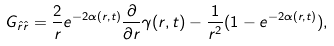Convert formula to latex. <formula><loc_0><loc_0><loc_500><loc_500>G _ { \hat { r } \hat { r } } = \frac { 2 } { r } e ^ { - 2 \alpha ( r , t ) } \frac { \partial } { \partial r } \gamma ( r , t ) - \frac { 1 } { r ^ { 2 } } ( 1 - e ^ { - 2 \alpha ( r , t ) } ) ,</formula> 